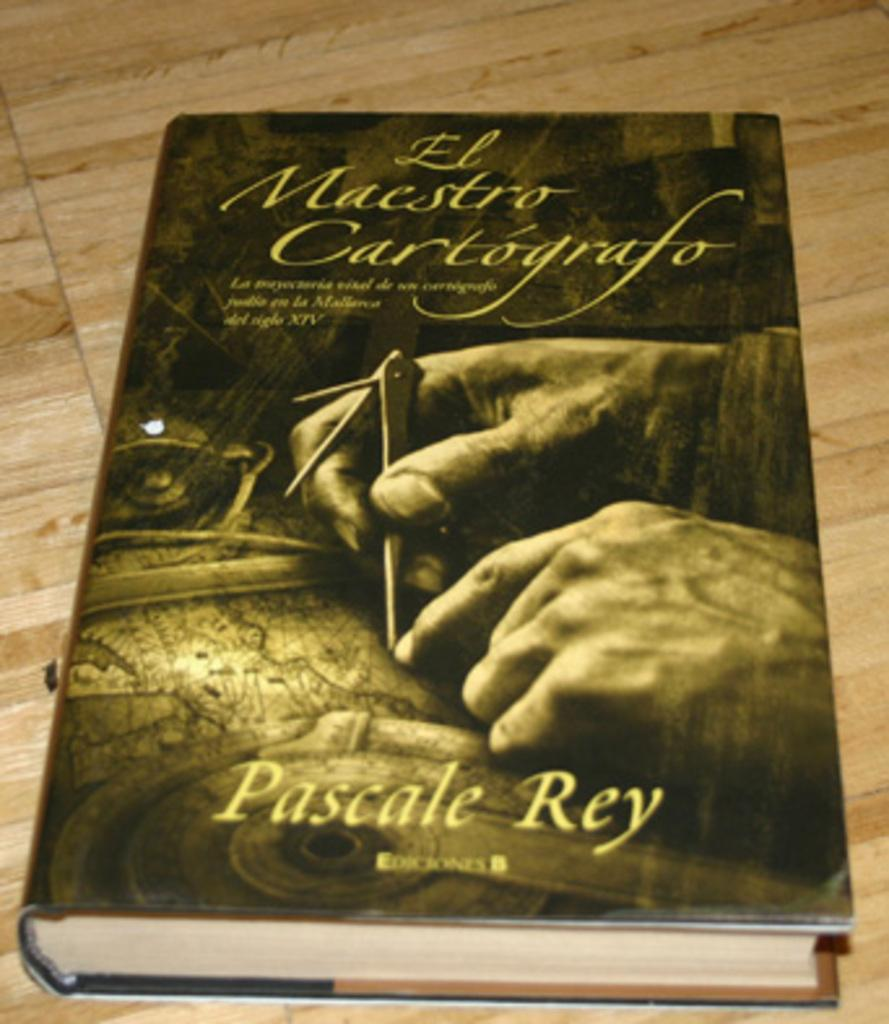<image>
Provide a brief description of the given image. A book by Pascale Rey shows hands using a compass on the cover. 